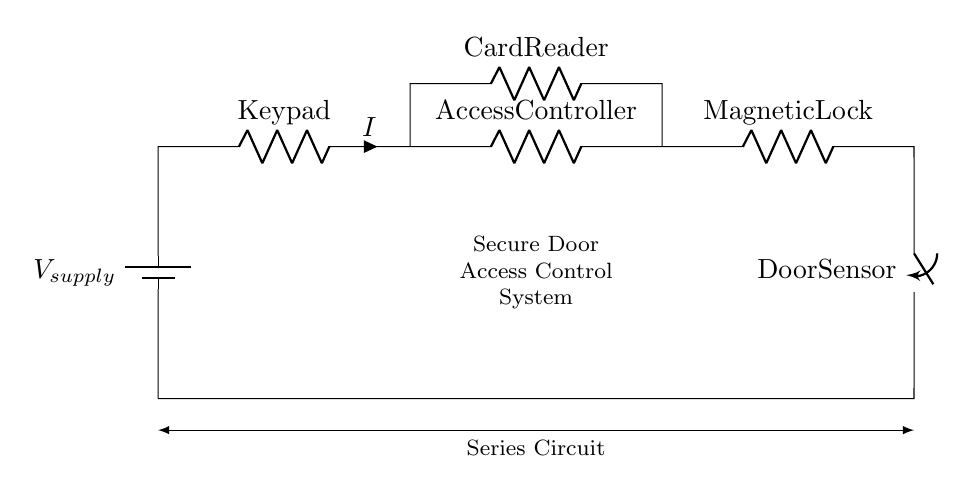What is the component type represented at the leftmost side of the circuit? The leftmost component is a battery, indicated by the symbol for a battery in the diagram. It serves as the power source for the circuit.
Answer: Battery What is the total number of resistive components in the series circuit? By counting the labels in the circuit, we see there are three resistive components: a keypad, an access controller, and a magnetic lock.
Answer: Three What is the purpose of the door sensor in this circuit? The door sensor is connected to the magnetic lock and acts as a switch to either close or open the circuit, enabling or disabling access based on the door's status.
Answer: Switch What is the output device in this secure door access control system? The output device in the circuit is the magnetic lock, which secures the door when the circuit is activated.
Answer: Magnetic lock What happens to the current flow if the door sensor is opened? If the door sensor is opened (switched off), the circuit breaks, causing the current flow to stop, thus disabling the magnetic lock.
Answer: Stops What type of circuit configuration is used in this system? The components are arranged in a single loop where the current flows through each device in sequence without any branches.
Answer: Series circuit What would increase the current in this circuit given constant voltage? Decreasing the total resistance of the circuit would lead to an increase in current, based on Ohm's Law, where current is inversely proportional to resistance when voltage is constant.
Answer: Decrease resistance 